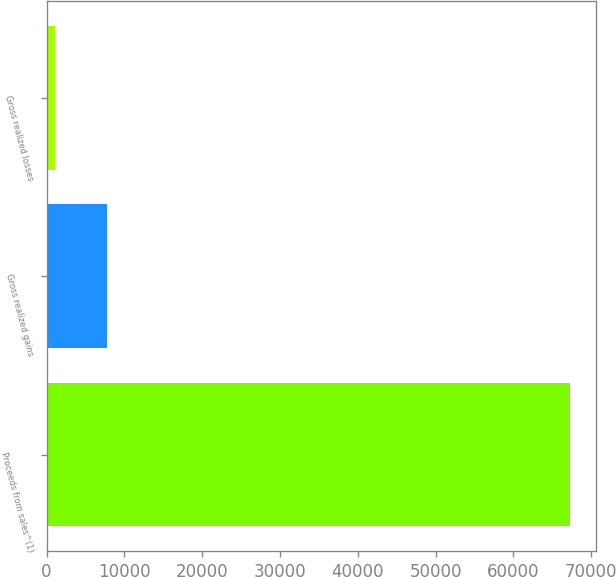Convert chart. <chart><loc_0><loc_0><loc_500><loc_500><bar_chart><fcel>Proceeds from sales^(1)<fcel>Gross realized gains<fcel>Gross realized losses<nl><fcel>67246<fcel>7714.6<fcel>1100<nl></chart> 